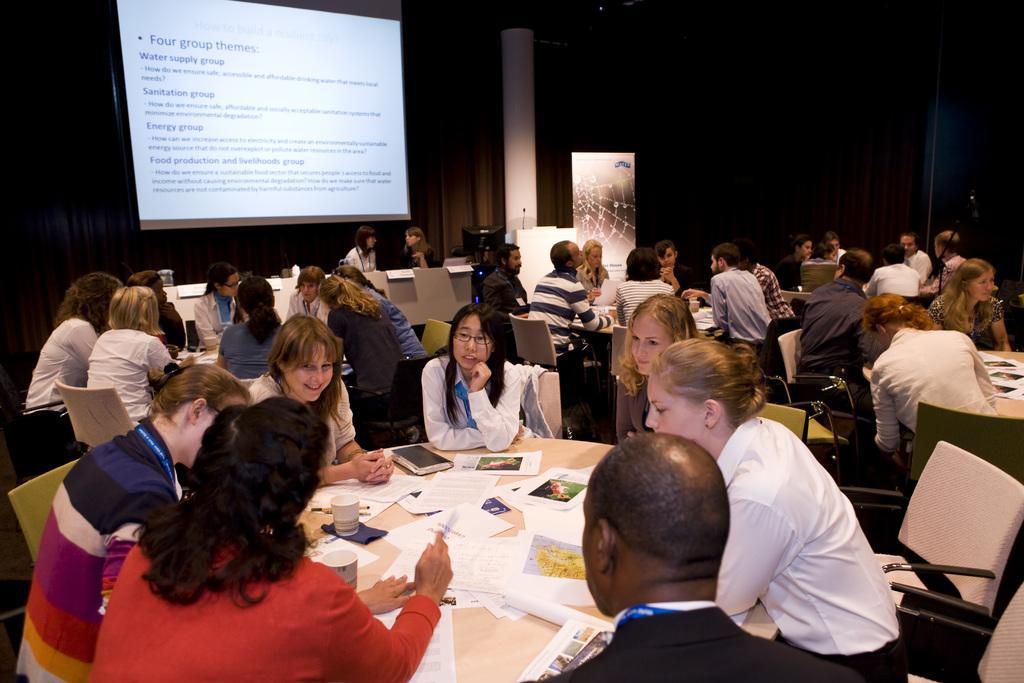Please provide a concise description of this image. In this image we can say group of people sitting on the chair. In front of the people there is a table. On table there are papers,cup and at the background there is pillar and a screen. 